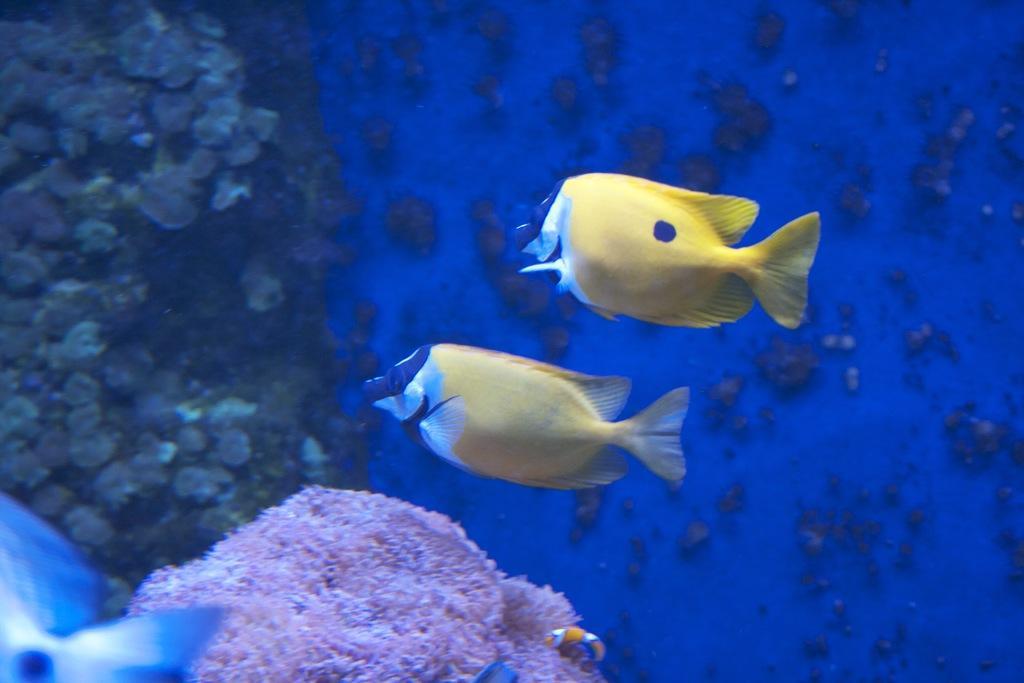Can you describe this image briefly? In the picture we can see a deep inside the sea with water stones and two fishes which are yellow in color and some part white in color. 